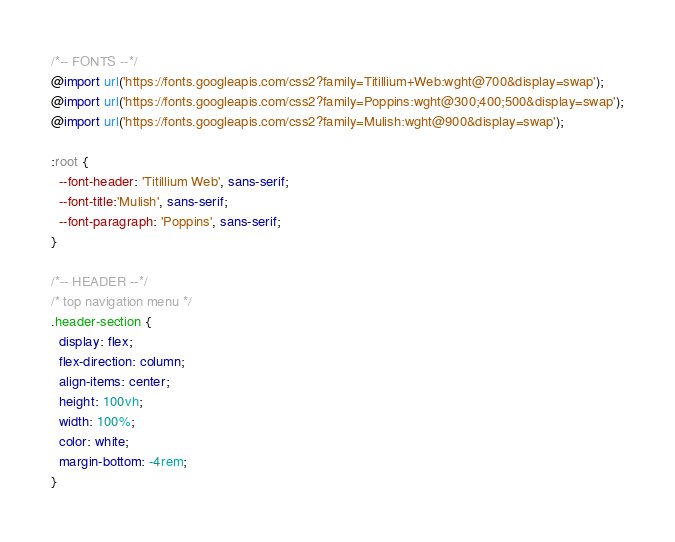<code> <loc_0><loc_0><loc_500><loc_500><_CSS_>/*-- FONTS --*/
@import url('https://fonts.googleapis.com/css2?family=Titillium+Web:wght@700&display=swap');
@import url('https://fonts.googleapis.com/css2?family=Poppins:wght@300;400;500&display=swap');
@import url('https://fonts.googleapis.com/css2?family=Mulish:wght@900&display=swap');

:root {
  --font-header: 'Titillium Web', sans-serif;
  --font-title:'Mulish', sans-serif;
  --font-paragraph: 'Poppins', sans-serif;
}

/*-- HEADER --*/
/* top navigation menu */
.header-section {
  display: flex;
  flex-direction: column;
  align-items: center;
  height: 100vh;
  width: 100%;
  color: white;
  margin-bottom: -4rem;
}</code> 